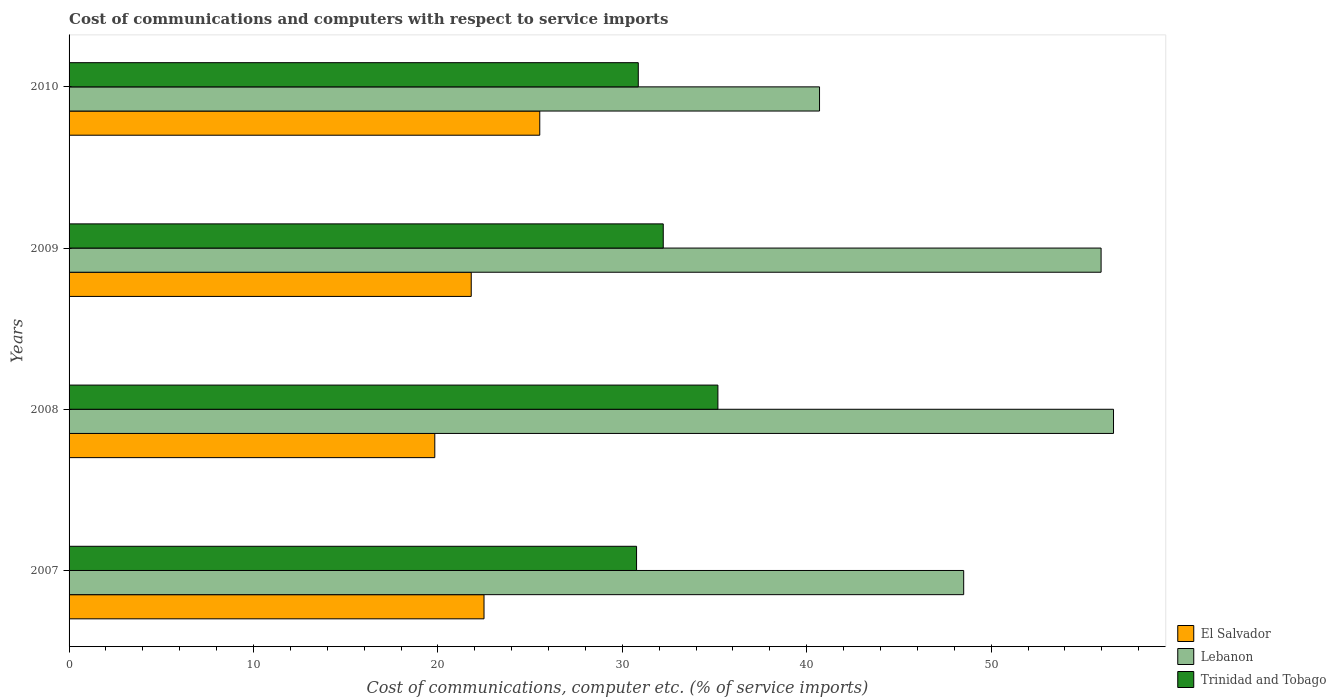How many different coloured bars are there?
Make the answer very short. 3. How many groups of bars are there?
Ensure brevity in your answer.  4. Are the number of bars per tick equal to the number of legend labels?
Offer a very short reply. Yes. Are the number of bars on each tick of the Y-axis equal?
Your response must be concise. Yes. What is the label of the 1st group of bars from the top?
Your answer should be very brief. 2010. What is the cost of communications and computers in Trinidad and Tobago in 2008?
Make the answer very short. 35.18. Across all years, what is the maximum cost of communications and computers in El Salvador?
Keep it short and to the point. 25.52. Across all years, what is the minimum cost of communications and computers in Lebanon?
Provide a succinct answer. 40.69. What is the total cost of communications and computers in Lebanon in the graph?
Offer a very short reply. 201.81. What is the difference between the cost of communications and computers in Lebanon in 2008 and that in 2010?
Keep it short and to the point. 15.94. What is the difference between the cost of communications and computers in El Salvador in 2009 and the cost of communications and computers in Trinidad and Tobago in 2007?
Your answer should be compact. -8.97. What is the average cost of communications and computers in El Salvador per year?
Offer a terse response. 22.42. In the year 2009, what is the difference between the cost of communications and computers in Lebanon and cost of communications and computers in Trinidad and Tobago?
Offer a very short reply. 23.74. What is the ratio of the cost of communications and computers in El Salvador in 2007 to that in 2009?
Offer a terse response. 1.03. Is the difference between the cost of communications and computers in Lebanon in 2007 and 2010 greater than the difference between the cost of communications and computers in Trinidad and Tobago in 2007 and 2010?
Provide a succinct answer. Yes. What is the difference between the highest and the second highest cost of communications and computers in Lebanon?
Provide a short and direct response. 0.67. What is the difference between the highest and the lowest cost of communications and computers in Lebanon?
Your answer should be very brief. 15.94. Is the sum of the cost of communications and computers in Trinidad and Tobago in 2008 and 2010 greater than the maximum cost of communications and computers in Lebanon across all years?
Offer a terse response. Yes. What does the 1st bar from the top in 2008 represents?
Your answer should be very brief. Trinidad and Tobago. What does the 1st bar from the bottom in 2010 represents?
Give a very brief answer. El Salvador. Is it the case that in every year, the sum of the cost of communications and computers in Trinidad and Tobago and cost of communications and computers in El Salvador is greater than the cost of communications and computers in Lebanon?
Your answer should be compact. No. Are all the bars in the graph horizontal?
Your answer should be very brief. Yes. How many years are there in the graph?
Offer a terse response. 4. Does the graph contain grids?
Ensure brevity in your answer.  No. How are the legend labels stacked?
Ensure brevity in your answer.  Vertical. What is the title of the graph?
Keep it short and to the point. Cost of communications and computers with respect to service imports. Does "Thailand" appear as one of the legend labels in the graph?
Your response must be concise. No. What is the label or title of the X-axis?
Provide a short and direct response. Cost of communications, computer etc. (% of service imports). What is the label or title of the Y-axis?
Provide a succinct answer. Years. What is the Cost of communications, computer etc. (% of service imports) of El Salvador in 2007?
Keep it short and to the point. 22.5. What is the Cost of communications, computer etc. (% of service imports) in Lebanon in 2007?
Your answer should be very brief. 48.51. What is the Cost of communications, computer etc. (% of service imports) of Trinidad and Tobago in 2007?
Provide a short and direct response. 30.77. What is the Cost of communications, computer etc. (% of service imports) in El Salvador in 2008?
Give a very brief answer. 19.83. What is the Cost of communications, computer etc. (% of service imports) in Lebanon in 2008?
Ensure brevity in your answer.  56.64. What is the Cost of communications, computer etc. (% of service imports) of Trinidad and Tobago in 2008?
Your answer should be very brief. 35.18. What is the Cost of communications, computer etc. (% of service imports) of El Salvador in 2009?
Give a very brief answer. 21.81. What is the Cost of communications, computer etc. (% of service imports) of Lebanon in 2009?
Make the answer very short. 55.96. What is the Cost of communications, computer etc. (% of service imports) of Trinidad and Tobago in 2009?
Your answer should be compact. 32.22. What is the Cost of communications, computer etc. (% of service imports) of El Salvador in 2010?
Offer a very short reply. 25.52. What is the Cost of communications, computer etc. (% of service imports) of Lebanon in 2010?
Keep it short and to the point. 40.69. What is the Cost of communications, computer etc. (% of service imports) in Trinidad and Tobago in 2010?
Ensure brevity in your answer.  30.87. Across all years, what is the maximum Cost of communications, computer etc. (% of service imports) of El Salvador?
Offer a terse response. 25.52. Across all years, what is the maximum Cost of communications, computer etc. (% of service imports) in Lebanon?
Your answer should be very brief. 56.64. Across all years, what is the maximum Cost of communications, computer etc. (% of service imports) of Trinidad and Tobago?
Make the answer very short. 35.18. Across all years, what is the minimum Cost of communications, computer etc. (% of service imports) in El Salvador?
Provide a succinct answer. 19.83. Across all years, what is the minimum Cost of communications, computer etc. (% of service imports) in Lebanon?
Your answer should be compact. 40.69. Across all years, what is the minimum Cost of communications, computer etc. (% of service imports) in Trinidad and Tobago?
Your answer should be compact. 30.77. What is the total Cost of communications, computer etc. (% of service imports) of El Salvador in the graph?
Ensure brevity in your answer.  89.67. What is the total Cost of communications, computer etc. (% of service imports) in Lebanon in the graph?
Your response must be concise. 201.81. What is the total Cost of communications, computer etc. (% of service imports) in Trinidad and Tobago in the graph?
Offer a terse response. 129.04. What is the difference between the Cost of communications, computer etc. (% of service imports) of El Salvador in 2007 and that in 2008?
Keep it short and to the point. 2.67. What is the difference between the Cost of communications, computer etc. (% of service imports) of Lebanon in 2007 and that in 2008?
Make the answer very short. -8.12. What is the difference between the Cost of communications, computer etc. (% of service imports) in Trinidad and Tobago in 2007 and that in 2008?
Offer a terse response. -4.41. What is the difference between the Cost of communications, computer etc. (% of service imports) of El Salvador in 2007 and that in 2009?
Keep it short and to the point. 0.69. What is the difference between the Cost of communications, computer etc. (% of service imports) in Lebanon in 2007 and that in 2009?
Make the answer very short. -7.45. What is the difference between the Cost of communications, computer etc. (% of service imports) of Trinidad and Tobago in 2007 and that in 2009?
Give a very brief answer. -1.45. What is the difference between the Cost of communications, computer etc. (% of service imports) in El Salvador in 2007 and that in 2010?
Offer a terse response. -3.02. What is the difference between the Cost of communications, computer etc. (% of service imports) in Lebanon in 2007 and that in 2010?
Offer a very short reply. 7.82. What is the difference between the Cost of communications, computer etc. (% of service imports) in Trinidad and Tobago in 2007 and that in 2010?
Provide a short and direct response. -0.09. What is the difference between the Cost of communications, computer etc. (% of service imports) in El Salvador in 2008 and that in 2009?
Offer a terse response. -1.98. What is the difference between the Cost of communications, computer etc. (% of service imports) of Lebanon in 2008 and that in 2009?
Make the answer very short. 0.67. What is the difference between the Cost of communications, computer etc. (% of service imports) in Trinidad and Tobago in 2008 and that in 2009?
Offer a terse response. 2.96. What is the difference between the Cost of communications, computer etc. (% of service imports) of El Salvador in 2008 and that in 2010?
Your response must be concise. -5.69. What is the difference between the Cost of communications, computer etc. (% of service imports) in Lebanon in 2008 and that in 2010?
Your response must be concise. 15.94. What is the difference between the Cost of communications, computer etc. (% of service imports) in Trinidad and Tobago in 2008 and that in 2010?
Offer a terse response. 4.32. What is the difference between the Cost of communications, computer etc. (% of service imports) in El Salvador in 2009 and that in 2010?
Your answer should be very brief. -3.72. What is the difference between the Cost of communications, computer etc. (% of service imports) in Lebanon in 2009 and that in 2010?
Ensure brevity in your answer.  15.27. What is the difference between the Cost of communications, computer etc. (% of service imports) of Trinidad and Tobago in 2009 and that in 2010?
Offer a terse response. 1.35. What is the difference between the Cost of communications, computer etc. (% of service imports) in El Salvador in 2007 and the Cost of communications, computer etc. (% of service imports) in Lebanon in 2008?
Provide a succinct answer. -34.14. What is the difference between the Cost of communications, computer etc. (% of service imports) of El Salvador in 2007 and the Cost of communications, computer etc. (% of service imports) of Trinidad and Tobago in 2008?
Your answer should be very brief. -12.68. What is the difference between the Cost of communications, computer etc. (% of service imports) in Lebanon in 2007 and the Cost of communications, computer etc. (% of service imports) in Trinidad and Tobago in 2008?
Give a very brief answer. 13.33. What is the difference between the Cost of communications, computer etc. (% of service imports) in El Salvador in 2007 and the Cost of communications, computer etc. (% of service imports) in Lebanon in 2009?
Your response must be concise. -33.46. What is the difference between the Cost of communications, computer etc. (% of service imports) of El Salvador in 2007 and the Cost of communications, computer etc. (% of service imports) of Trinidad and Tobago in 2009?
Make the answer very short. -9.72. What is the difference between the Cost of communications, computer etc. (% of service imports) of Lebanon in 2007 and the Cost of communications, computer etc. (% of service imports) of Trinidad and Tobago in 2009?
Offer a very short reply. 16.29. What is the difference between the Cost of communications, computer etc. (% of service imports) in El Salvador in 2007 and the Cost of communications, computer etc. (% of service imports) in Lebanon in 2010?
Give a very brief answer. -18.19. What is the difference between the Cost of communications, computer etc. (% of service imports) of El Salvador in 2007 and the Cost of communications, computer etc. (% of service imports) of Trinidad and Tobago in 2010?
Your answer should be very brief. -8.36. What is the difference between the Cost of communications, computer etc. (% of service imports) of Lebanon in 2007 and the Cost of communications, computer etc. (% of service imports) of Trinidad and Tobago in 2010?
Provide a succinct answer. 17.65. What is the difference between the Cost of communications, computer etc. (% of service imports) in El Salvador in 2008 and the Cost of communications, computer etc. (% of service imports) in Lebanon in 2009?
Provide a short and direct response. -36.13. What is the difference between the Cost of communications, computer etc. (% of service imports) of El Salvador in 2008 and the Cost of communications, computer etc. (% of service imports) of Trinidad and Tobago in 2009?
Your answer should be very brief. -12.39. What is the difference between the Cost of communications, computer etc. (% of service imports) in Lebanon in 2008 and the Cost of communications, computer etc. (% of service imports) in Trinidad and Tobago in 2009?
Offer a very short reply. 24.42. What is the difference between the Cost of communications, computer etc. (% of service imports) in El Salvador in 2008 and the Cost of communications, computer etc. (% of service imports) in Lebanon in 2010?
Your answer should be very brief. -20.86. What is the difference between the Cost of communications, computer etc. (% of service imports) in El Salvador in 2008 and the Cost of communications, computer etc. (% of service imports) in Trinidad and Tobago in 2010?
Provide a short and direct response. -11.03. What is the difference between the Cost of communications, computer etc. (% of service imports) in Lebanon in 2008 and the Cost of communications, computer etc. (% of service imports) in Trinidad and Tobago in 2010?
Your answer should be compact. 25.77. What is the difference between the Cost of communications, computer etc. (% of service imports) of El Salvador in 2009 and the Cost of communications, computer etc. (% of service imports) of Lebanon in 2010?
Make the answer very short. -18.89. What is the difference between the Cost of communications, computer etc. (% of service imports) in El Salvador in 2009 and the Cost of communications, computer etc. (% of service imports) in Trinidad and Tobago in 2010?
Provide a succinct answer. -9.06. What is the difference between the Cost of communications, computer etc. (% of service imports) in Lebanon in 2009 and the Cost of communications, computer etc. (% of service imports) in Trinidad and Tobago in 2010?
Your response must be concise. 25.1. What is the average Cost of communications, computer etc. (% of service imports) in El Salvador per year?
Give a very brief answer. 22.42. What is the average Cost of communications, computer etc. (% of service imports) in Lebanon per year?
Offer a terse response. 50.45. What is the average Cost of communications, computer etc. (% of service imports) in Trinidad and Tobago per year?
Offer a very short reply. 32.26. In the year 2007, what is the difference between the Cost of communications, computer etc. (% of service imports) in El Salvador and Cost of communications, computer etc. (% of service imports) in Lebanon?
Provide a short and direct response. -26.01. In the year 2007, what is the difference between the Cost of communications, computer etc. (% of service imports) in El Salvador and Cost of communications, computer etc. (% of service imports) in Trinidad and Tobago?
Offer a very short reply. -8.27. In the year 2007, what is the difference between the Cost of communications, computer etc. (% of service imports) in Lebanon and Cost of communications, computer etc. (% of service imports) in Trinidad and Tobago?
Ensure brevity in your answer.  17.74. In the year 2008, what is the difference between the Cost of communications, computer etc. (% of service imports) of El Salvador and Cost of communications, computer etc. (% of service imports) of Lebanon?
Provide a short and direct response. -36.8. In the year 2008, what is the difference between the Cost of communications, computer etc. (% of service imports) in El Salvador and Cost of communications, computer etc. (% of service imports) in Trinidad and Tobago?
Give a very brief answer. -15.35. In the year 2008, what is the difference between the Cost of communications, computer etc. (% of service imports) of Lebanon and Cost of communications, computer etc. (% of service imports) of Trinidad and Tobago?
Your answer should be very brief. 21.45. In the year 2009, what is the difference between the Cost of communications, computer etc. (% of service imports) of El Salvador and Cost of communications, computer etc. (% of service imports) of Lebanon?
Provide a short and direct response. -34.16. In the year 2009, what is the difference between the Cost of communications, computer etc. (% of service imports) of El Salvador and Cost of communications, computer etc. (% of service imports) of Trinidad and Tobago?
Your answer should be compact. -10.41. In the year 2009, what is the difference between the Cost of communications, computer etc. (% of service imports) of Lebanon and Cost of communications, computer etc. (% of service imports) of Trinidad and Tobago?
Give a very brief answer. 23.74. In the year 2010, what is the difference between the Cost of communications, computer etc. (% of service imports) in El Salvador and Cost of communications, computer etc. (% of service imports) in Lebanon?
Provide a succinct answer. -15.17. In the year 2010, what is the difference between the Cost of communications, computer etc. (% of service imports) of El Salvador and Cost of communications, computer etc. (% of service imports) of Trinidad and Tobago?
Your answer should be compact. -5.34. In the year 2010, what is the difference between the Cost of communications, computer etc. (% of service imports) in Lebanon and Cost of communications, computer etc. (% of service imports) in Trinidad and Tobago?
Your answer should be very brief. 9.83. What is the ratio of the Cost of communications, computer etc. (% of service imports) of El Salvador in 2007 to that in 2008?
Provide a succinct answer. 1.13. What is the ratio of the Cost of communications, computer etc. (% of service imports) in Lebanon in 2007 to that in 2008?
Your answer should be very brief. 0.86. What is the ratio of the Cost of communications, computer etc. (% of service imports) of Trinidad and Tobago in 2007 to that in 2008?
Your answer should be very brief. 0.87. What is the ratio of the Cost of communications, computer etc. (% of service imports) in El Salvador in 2007 to that in 2009?
Keep it short and to the point. 1.03. What is the ratio of the Cost of communications, computer etc. (% of service imports) in Lebanon in 2007 to that in 2009?
Keep it short and to the point. 0.87. What is the ratio of the Cost of communications, computer etc. (% of service imports) of Trinidad and Tobago in 2007 to that in 2009?
Provide a succinct answer. 0.96. What is the ratio of the Cost of communications, computer etc. (% of service imports) of El Salvador in 2007 to that in 2010?
Offer a terse response. 0.88. What is the ratio of the Cost of communications, computer etc. (% of service imports) of Lebanon in 2007 to that in 2010?
Your answer should be very brief. 1.19. What is the ratio of the Cost of communications, computer etc. (% of service imports) in Trinidad and Tobago in 2007 to that in 2010?
Your answer should be compact. 1. What is the ratio of the Cost of communications, computer etc. (% of service imports) of El Salvador in 2008 to that in 2009?
Provide a succinct answer. 0.91. What is the ratio of the Cost of communications, computer etc. (% of service imports) in Trinidad and Tobago in 2008 to that in 2009?
Provide a succinct answer. 1.09. What is the ratio of the Cost of communications, computer etc. (% of service imports) of El Salvador in 2008 to that in 2010?
Your answer should be very brief. 0.78. What is the ratio of the Cost of communications, computer etc. (% of service imports) in Lebanon in 2008 to that in 2010?
Provide a short and direct response. 1.39. What is the ratio of the Cost of communications, computer etc. (% of service imports) of Trinidad and Tobago in 2008 to that in 2010?
Give a very brief answer. 1.14. What is the ratio of the Cost of communications, computer etc. (% of service imports) of El Salvador in 2009 to that in 2010?
Ensure brevity in your answer.  0.85. What is the ratio of the Cost of communications, computer etc. (% of service imports) of Lebanon in 2009 to that in 2010?
Offer a terse response. 1.38. What is the ratio of the Cost of communications, computer etc. (% of service imports) in Trinidad and Tobago in 2009 to that in 2010?
Offer a very short reply. 1.04. What is the difference between the highest and the second highest Cost of communications, computer etc. (% of service imports) of El Salvador?
Your response must be concise. 3.02. What is the difference between the highest and the second highest Cost of communications, computer etc. (% of service imports) in Lebanon?
Keep it short and to the point. 0.67. What is the difference between the highest and the second highest Cost of communications, computer etc. (% of service imports) of Trinidad and Tobago?
Your answer should be compact. 2.96. What is the difference between the highest and the lowest Cost of communications, computer etc. (% of service imports) of El Salvador?
Keep it short and to the point. 5.69. What is the difference between the highest and the lowest Cost of communications, computer etc. (% of service imports) in Lebanon?
Provide a short and direct response. 15.94. What is the difference between the highest and the lowest Cost of communications, computer etc. (% of service imports) in Trinidad and Tobago?
Ensure brevity in your answer.  4.41. 